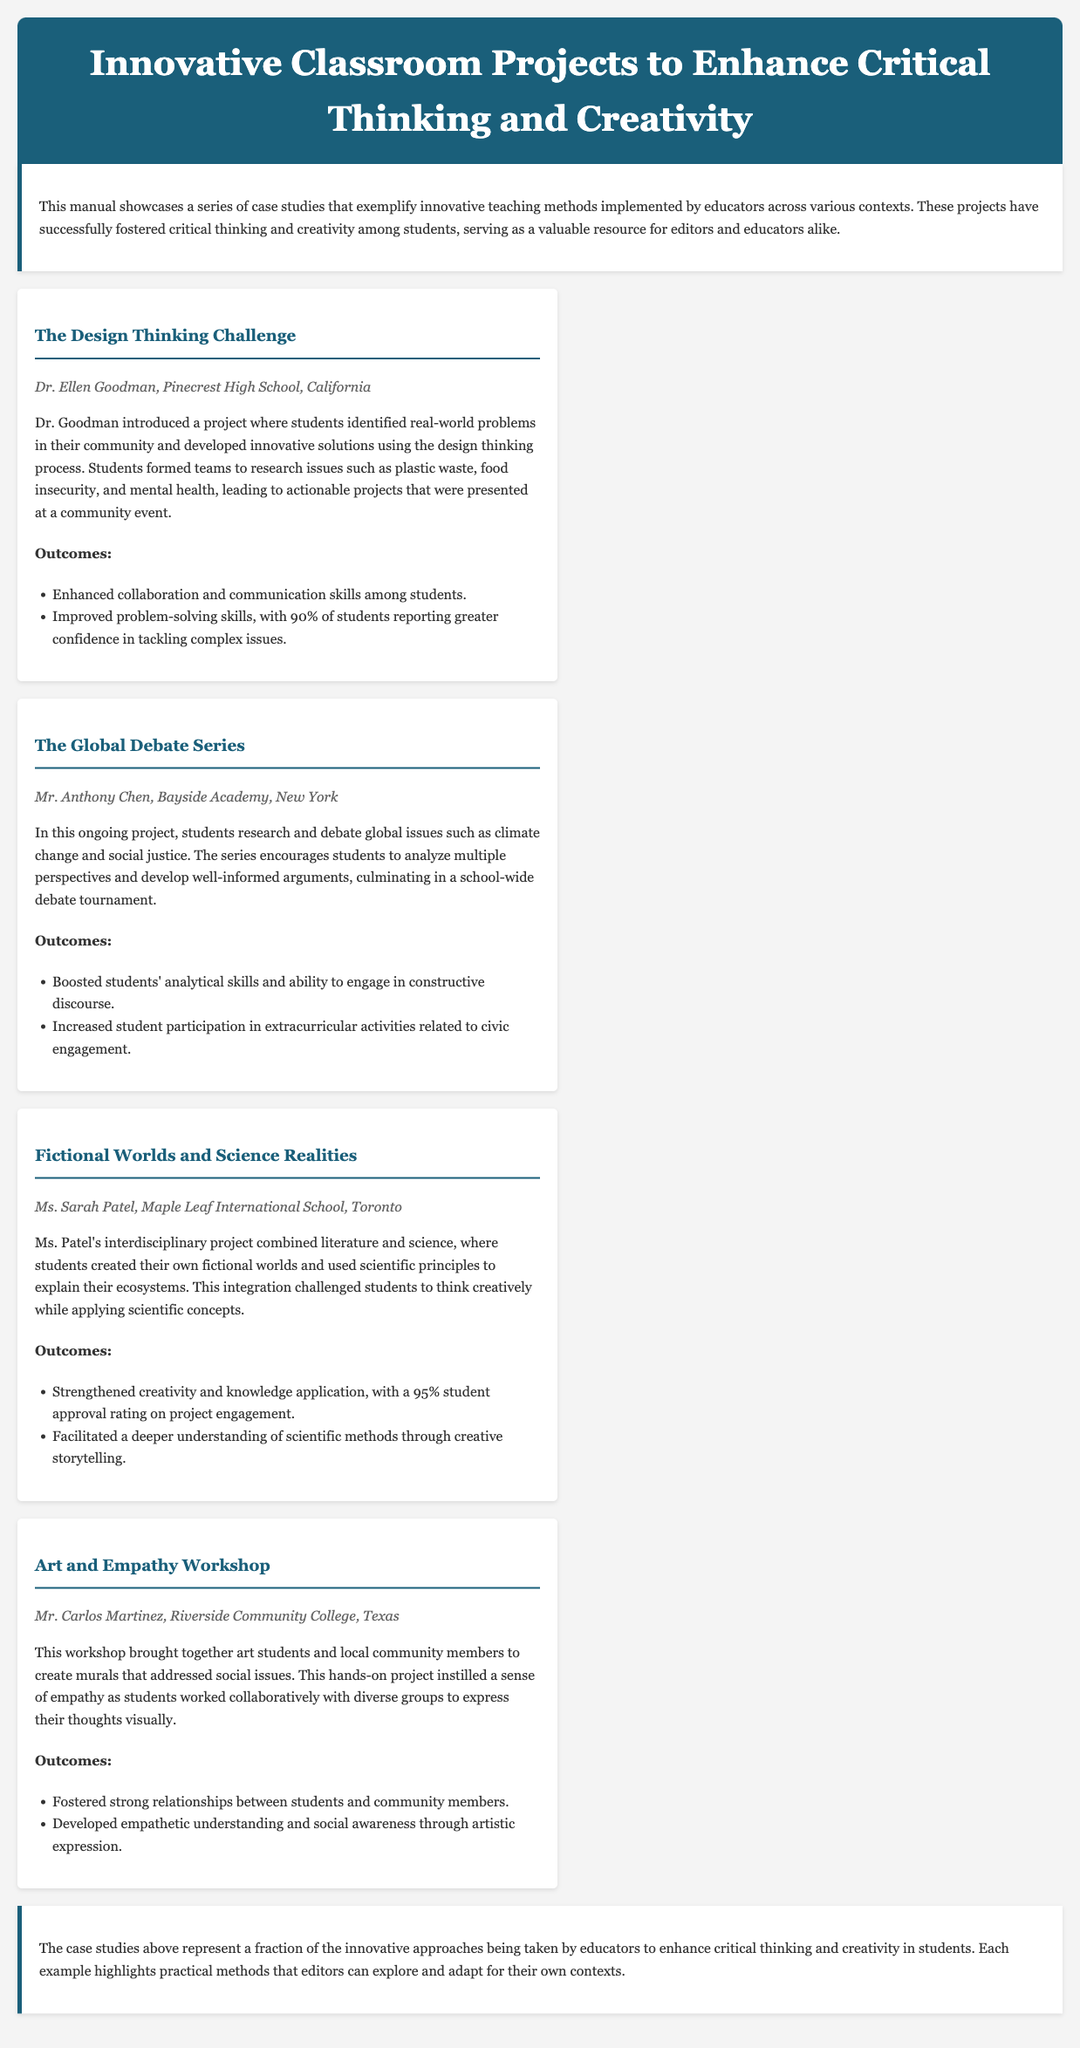What is the title of the manual? The title of the manual is indicated in the header section, which provides the primary information about its content.
Answer: Innovative Classroom Projects to Enhance Critical Thinking and Creativity Who is the educator for the Design Thinking Challenge project? The manual contains specific information about each project and lists the respective educators involved.
Answer: Dr. Ellen Goodman What percentage of students reported greater confidence in tackling complex issues after the Design Thinking Challenge? The outcome section provides a numerical result reflecting student confidence after participation in the project.
Answer: 90% What is the main focus of the Global Debate Series? The project description outlines the central theme of the Global Debate Series and what it aims to achieve through student participation.
Answer: Global issues Which case study integrated literature and science? Each case study is distinctly titled, reflecting its unique focus and approach to education.
Answer: Fictional Worlds and Science Realities What was a notable outcome of the Art and Empathy Workshop? The outcomes listed for each project demonstrate the impact on students and the community, providing specific benefits that were observed.
Answer: Developed empathetic understanding and social awareness through artistic expression What type of projects does the manual showcase? The introduction provides a general overview of the content and the purpose behind the showcased examples, highlighting their educational aims.
Answer: Innovative teaching methods How many case studies are presented in the manual? By reviewing the content structure, we can determine the total number of distinct sections dedicated to individual projects.
Answer: Four 